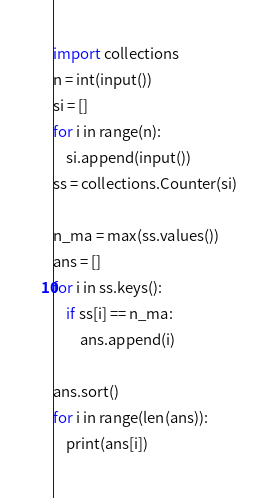Convert code to text. <code><loc_0><loc_0><loc_500><loc_500><_Python_>import collections
n = int(input())
si = []
for i in range(n):
    si.append(input())
ss = collections.Counter(si)

n_ma = max(ss.values())
ans = []
for i in ss.keys():
    if ss[i] == n_ma:
        ans.append(i)

ans.sort()
for i in range(len(ans)):
    print(ans[i])</code> 